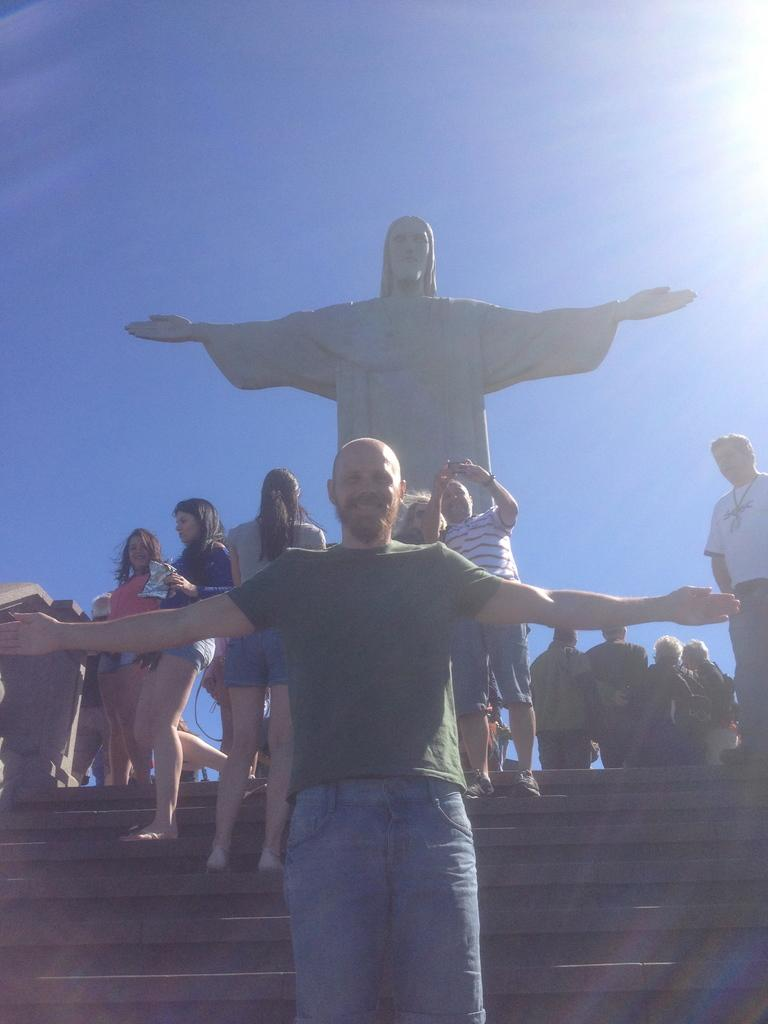How many people are present in the image? There are many people in the image. What are some of the people doing in the image? Some people are standing on stairs. What can be seen in the background of the image? There is a Christ Redeemer statue and the sky visible in the background. What type of patch is being used to balance the copper in the image? There is no patch or copper present in the image. 